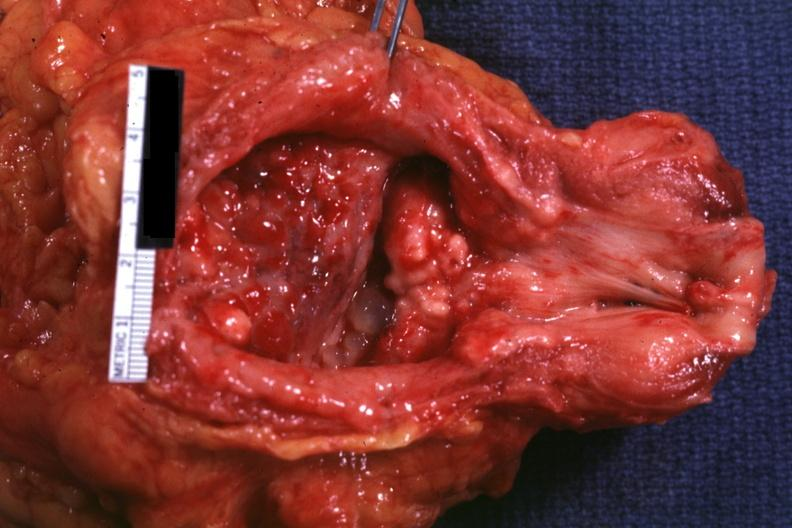s adenocarcinoma present?
Answer the question using a single word or phrase. Yes 